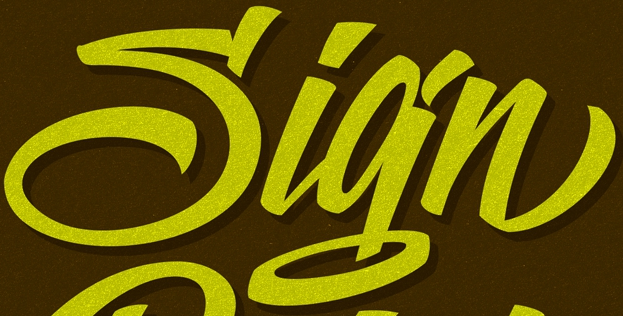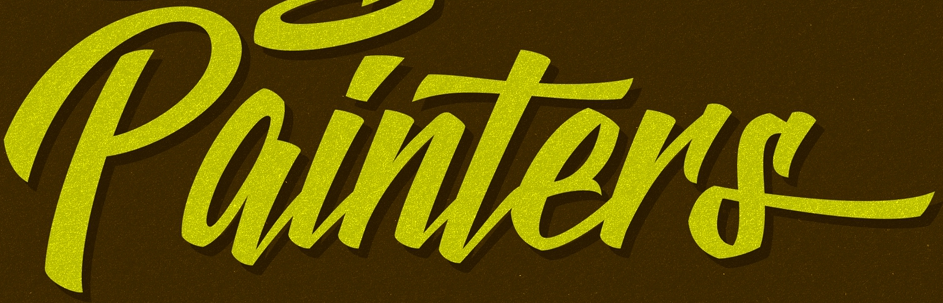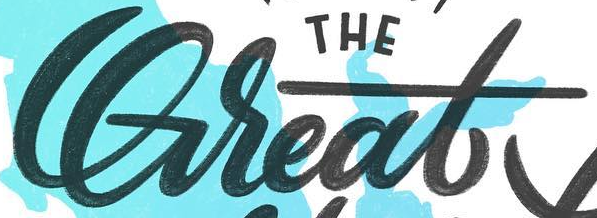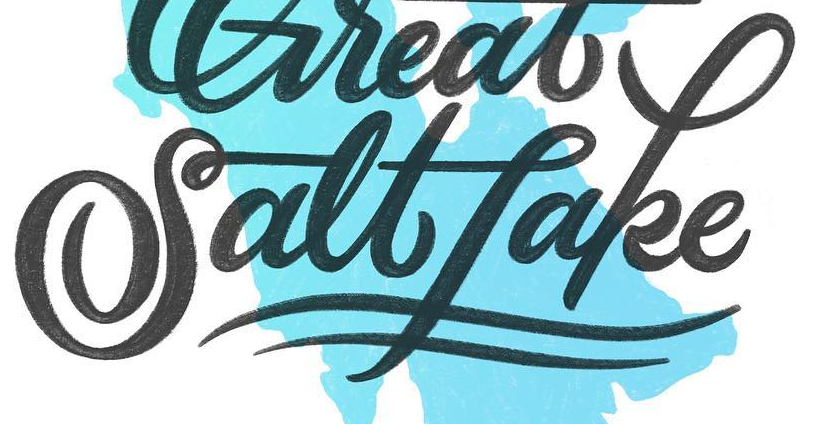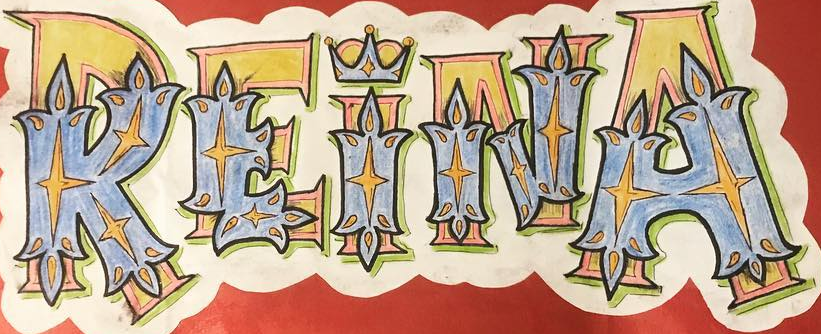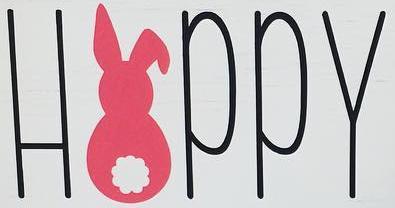Transcribe the words shown in these images in order, separated by a semicolon. Sign; painTers; Great; Saltfake; REINA; HAPPY 